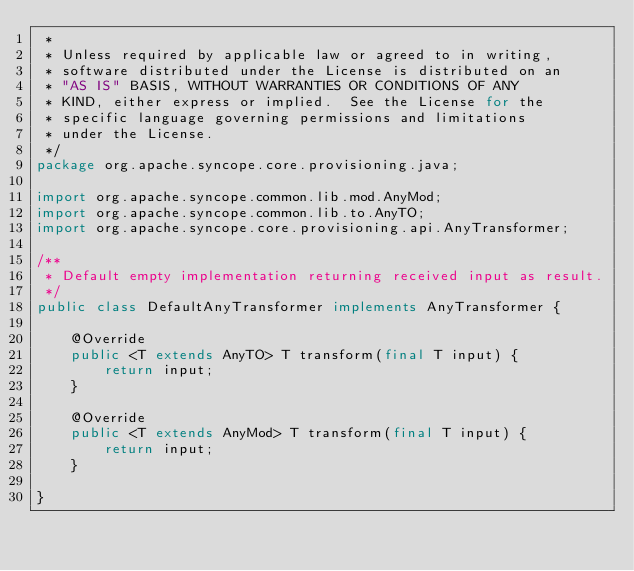Convert code to text. <code><loc_0><loc_0><loc_500><loc_500><_Java_> *
 * Unless required by applicable law or agreed to in writing,
 * software distributed under the License is distributed on an
 * "AS IS" BASIS, WITHOUT WARRANTIES OR CONDITIONS OF ANY
 * KIND, either express or implied.  See the License for the
 * specific language governing permissions and limitations
 * under the License.
 */
package org.apache.syncope.core.provisioning.java;

import org.apache.syncope.common.lib.mod.AnyMod;
import org.apache.syncope.common.lib.to.AnyTO;
import org.apache.syncope.core.provisioning.api.AnyTransformer;

/**
 * Default empty implementation returning received input as result.
 */
public class DefaultAnyTransformer implements AnyTransformer {

    @Override
    public <T extends AnyTO> T transform(final T input) {
        return input;
    }

    @Override
    public <T extends AnyMod> T transform(final T input) {
        return input;
    }

}
</code> 